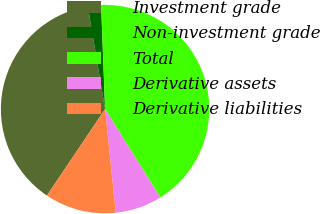Convert chart. <chart><loc_0><loc_0><loc_500><loc_500><pie_chart><fcel>Investment grade<fcel>Non-investment grade<fcel>Total<fcel>Derivative assets<fcel>Derivative liabilities<nl><fcel>37.92%<fcel>2.05%<fcel>41.71%<fcel>7.27%<fcel>11.06%<nl></chart> 